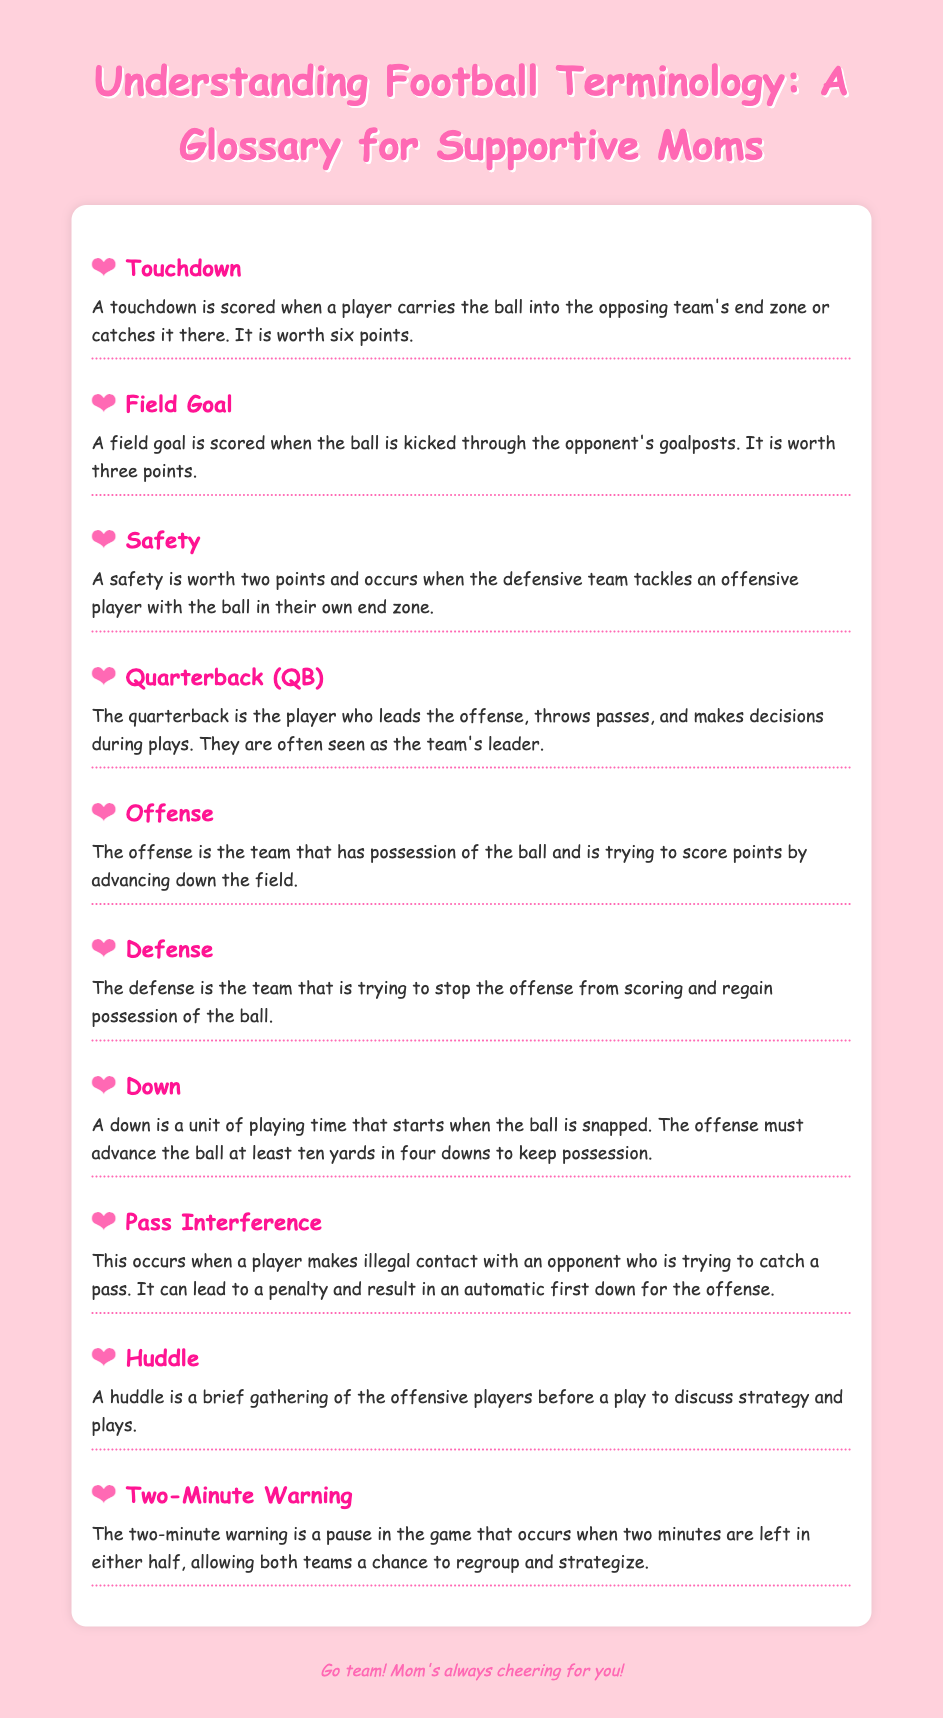What is a touchdown? A touchdown is scored when a player carries the ball into the opposing team's end zone or catches it there.
Answer: A touchdown is scored when a player carries the ball into the opposing team's end zone or catches it there How many points is a field goal worth? A field goal is scored when the ball is kicked through the opponent's goalposts, and it is worth three points.
Answer: Three points What happens during a safety? A safety occurs when the defensive team tackles an offensive player with the ball in their own end zone, which is worth two points.
Answer: A safety is worth two points and occurs when the defensive team tackles an offensive player with the ball in their own end zone Who is the leader of the offense? The quarterback is the player who leads the offense, throws passes, and makes decisions during plays.
Answer: The quarterback What does the defense do? The defense is trying to stop the offense from scoring and regain possession of the ball.
Answer: Stop the offense from scoring What is a down? A down is a unit of playing time that starts when the ball is snapped, and the offense must advance the ball at least ten yards in four downs.
Answer: A down is a unit of playing time What is pass interference? Pass interference occurs when a player makes illegal contact with an opponent who is trying to catch a pass, leading to a penalty.
Answer: A player makes illegal contact What is the purpose of a huddle? A huddle is a brief gathering of the offensive players before a play to discuss strategy and plays.
Answer: Discuss strategy and plays When does the two-minute warning occur? The two-minute warning occurs when two minutes are left in either half of the game.
Answer: Two minutes left in either half 